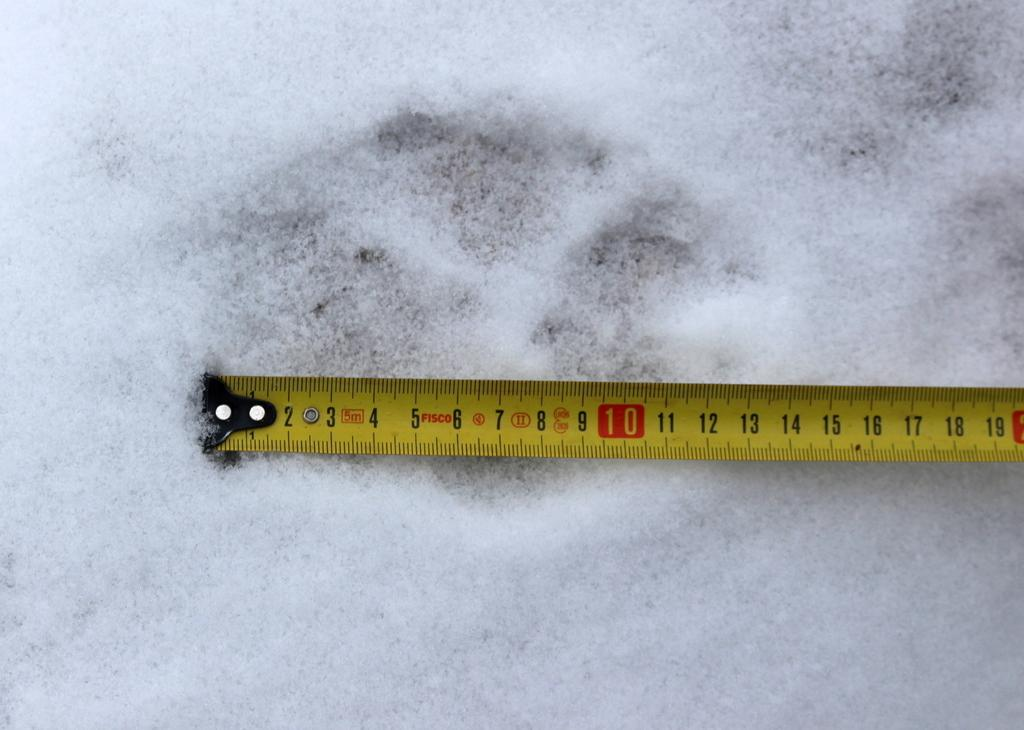<image>
Summarize the visual content of the image. The yellow tape measure out in the snow reaches out to just over 19cm. 